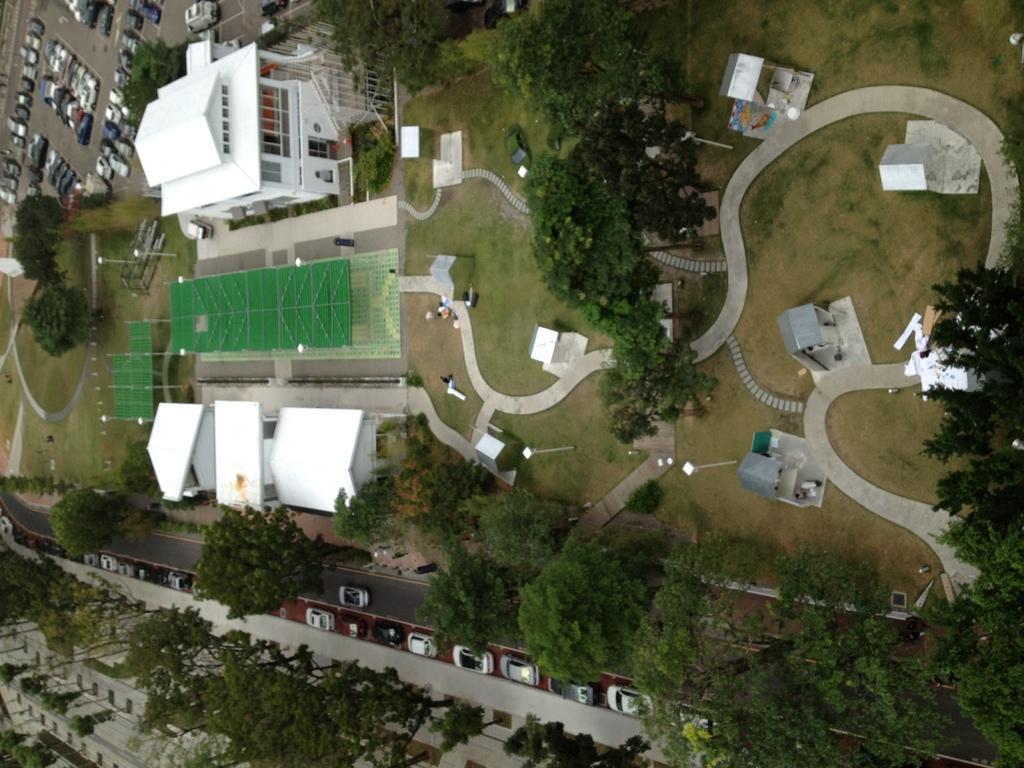Describe this image in one or two sentences. It is the aerial view of an area there are plenty of trees, a house and behind the house there are many vehicles parked in the parking area and on the left side there are many cars beside the road and around that house there are many paths interlinked throughout the ground. 